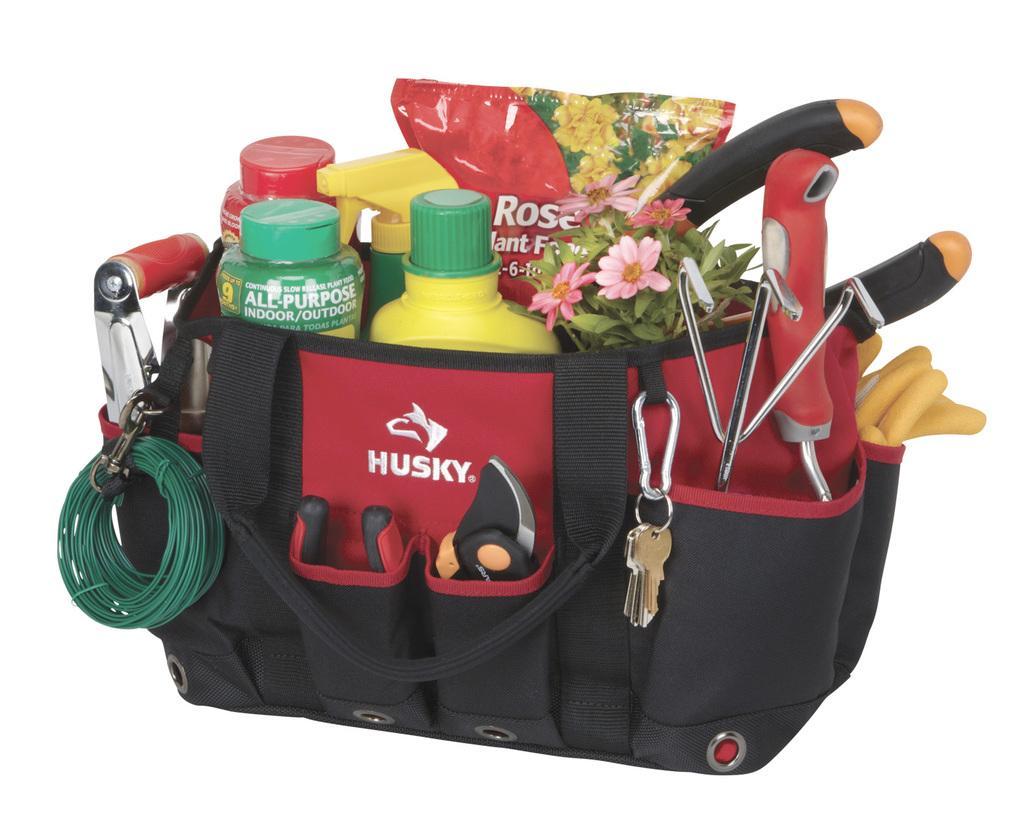In one or two sentences, can you explain what this image depicts? This is the picture of a bag in which there are some things placed bottle, flowers, wire and keys. 